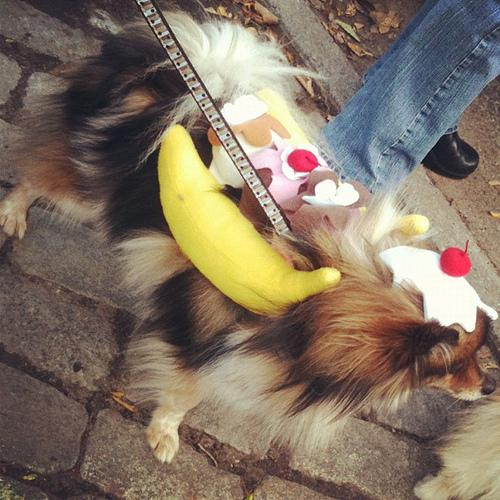Question: what is the dog wearing?
Choices:
A. A colar.
B. A harness.
C. A sweater.
D. A costume.
Answer with the letter. Answer: D Question: what is the walkway made of?
Choices:
A. Stone.
B. Bricks.
C. Cement.
D. Asphalt.
Answer with the letter. Answer: A Question: where is the cherry?
Choices:
A. In the tree.
B. In the pie.
C. The dog's head.
D. On a plate.
Answer with the letter. Answer: C Question: who is wearing an ice cream sundae costume?
Choices:
A. The little girl.
B. A woman.
C. The dog.
D. A man.
Answer with the letter. Answer: C Question: what kind of fur does the dog have?
Choices:
A. Thick.
B. Long.
C. Dirty.
D. Shiney.
Answer with the letter. Answer: B 